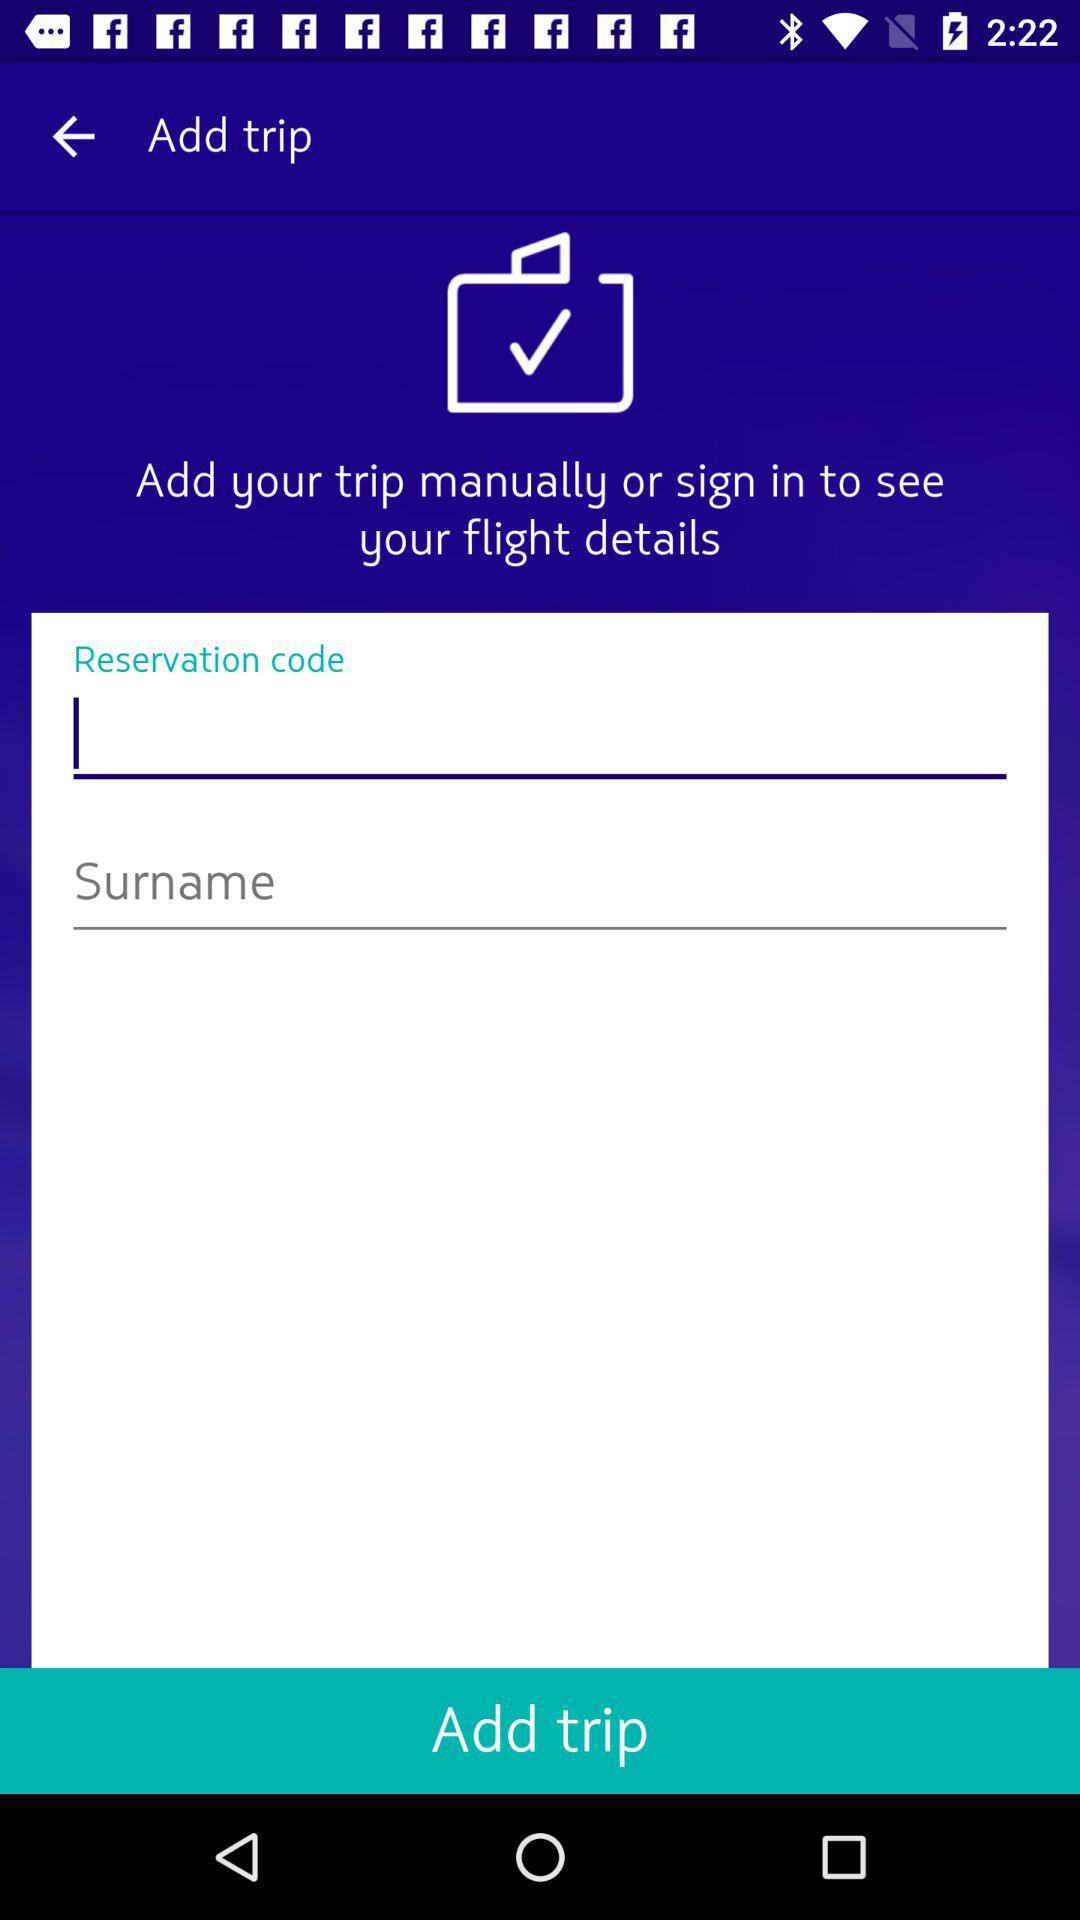How many more text inputs are there after the reservation code than before?
Answer the question using a single word or phrase. 1 